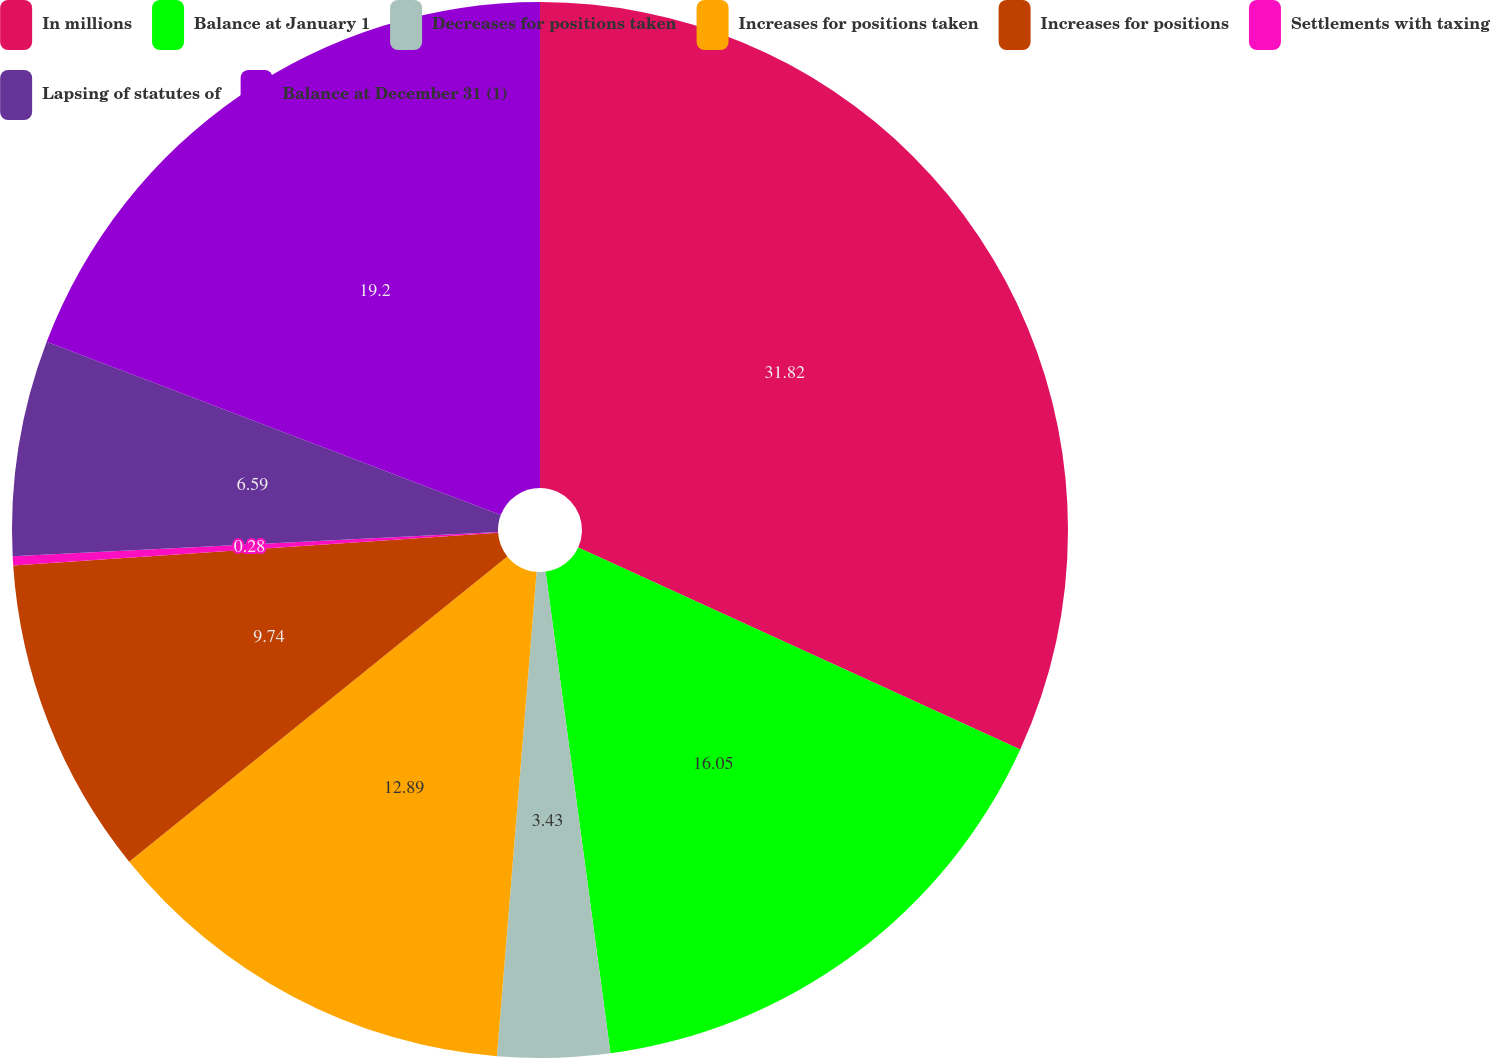<chart> <loc_0><loc_0><loc_500><loc_500><pie_chart><fcel>In millions<fcel>Balance at January 1<fcel>Decreases for positions taken<fcel>Increases for positions taken<fcel>Increases for positions<fcel>Settlements with taxing<fcel>Lapsing of statutes of<fcel>Balance at December 31 (1)<nl><fcel>31.82%<fcel>16.05%<fcel>3.43%<fcel>12.89%<fcel>9.74%<fcel>0.28%<fcel>6.59%<fcel>19.2%<nl></chart> 